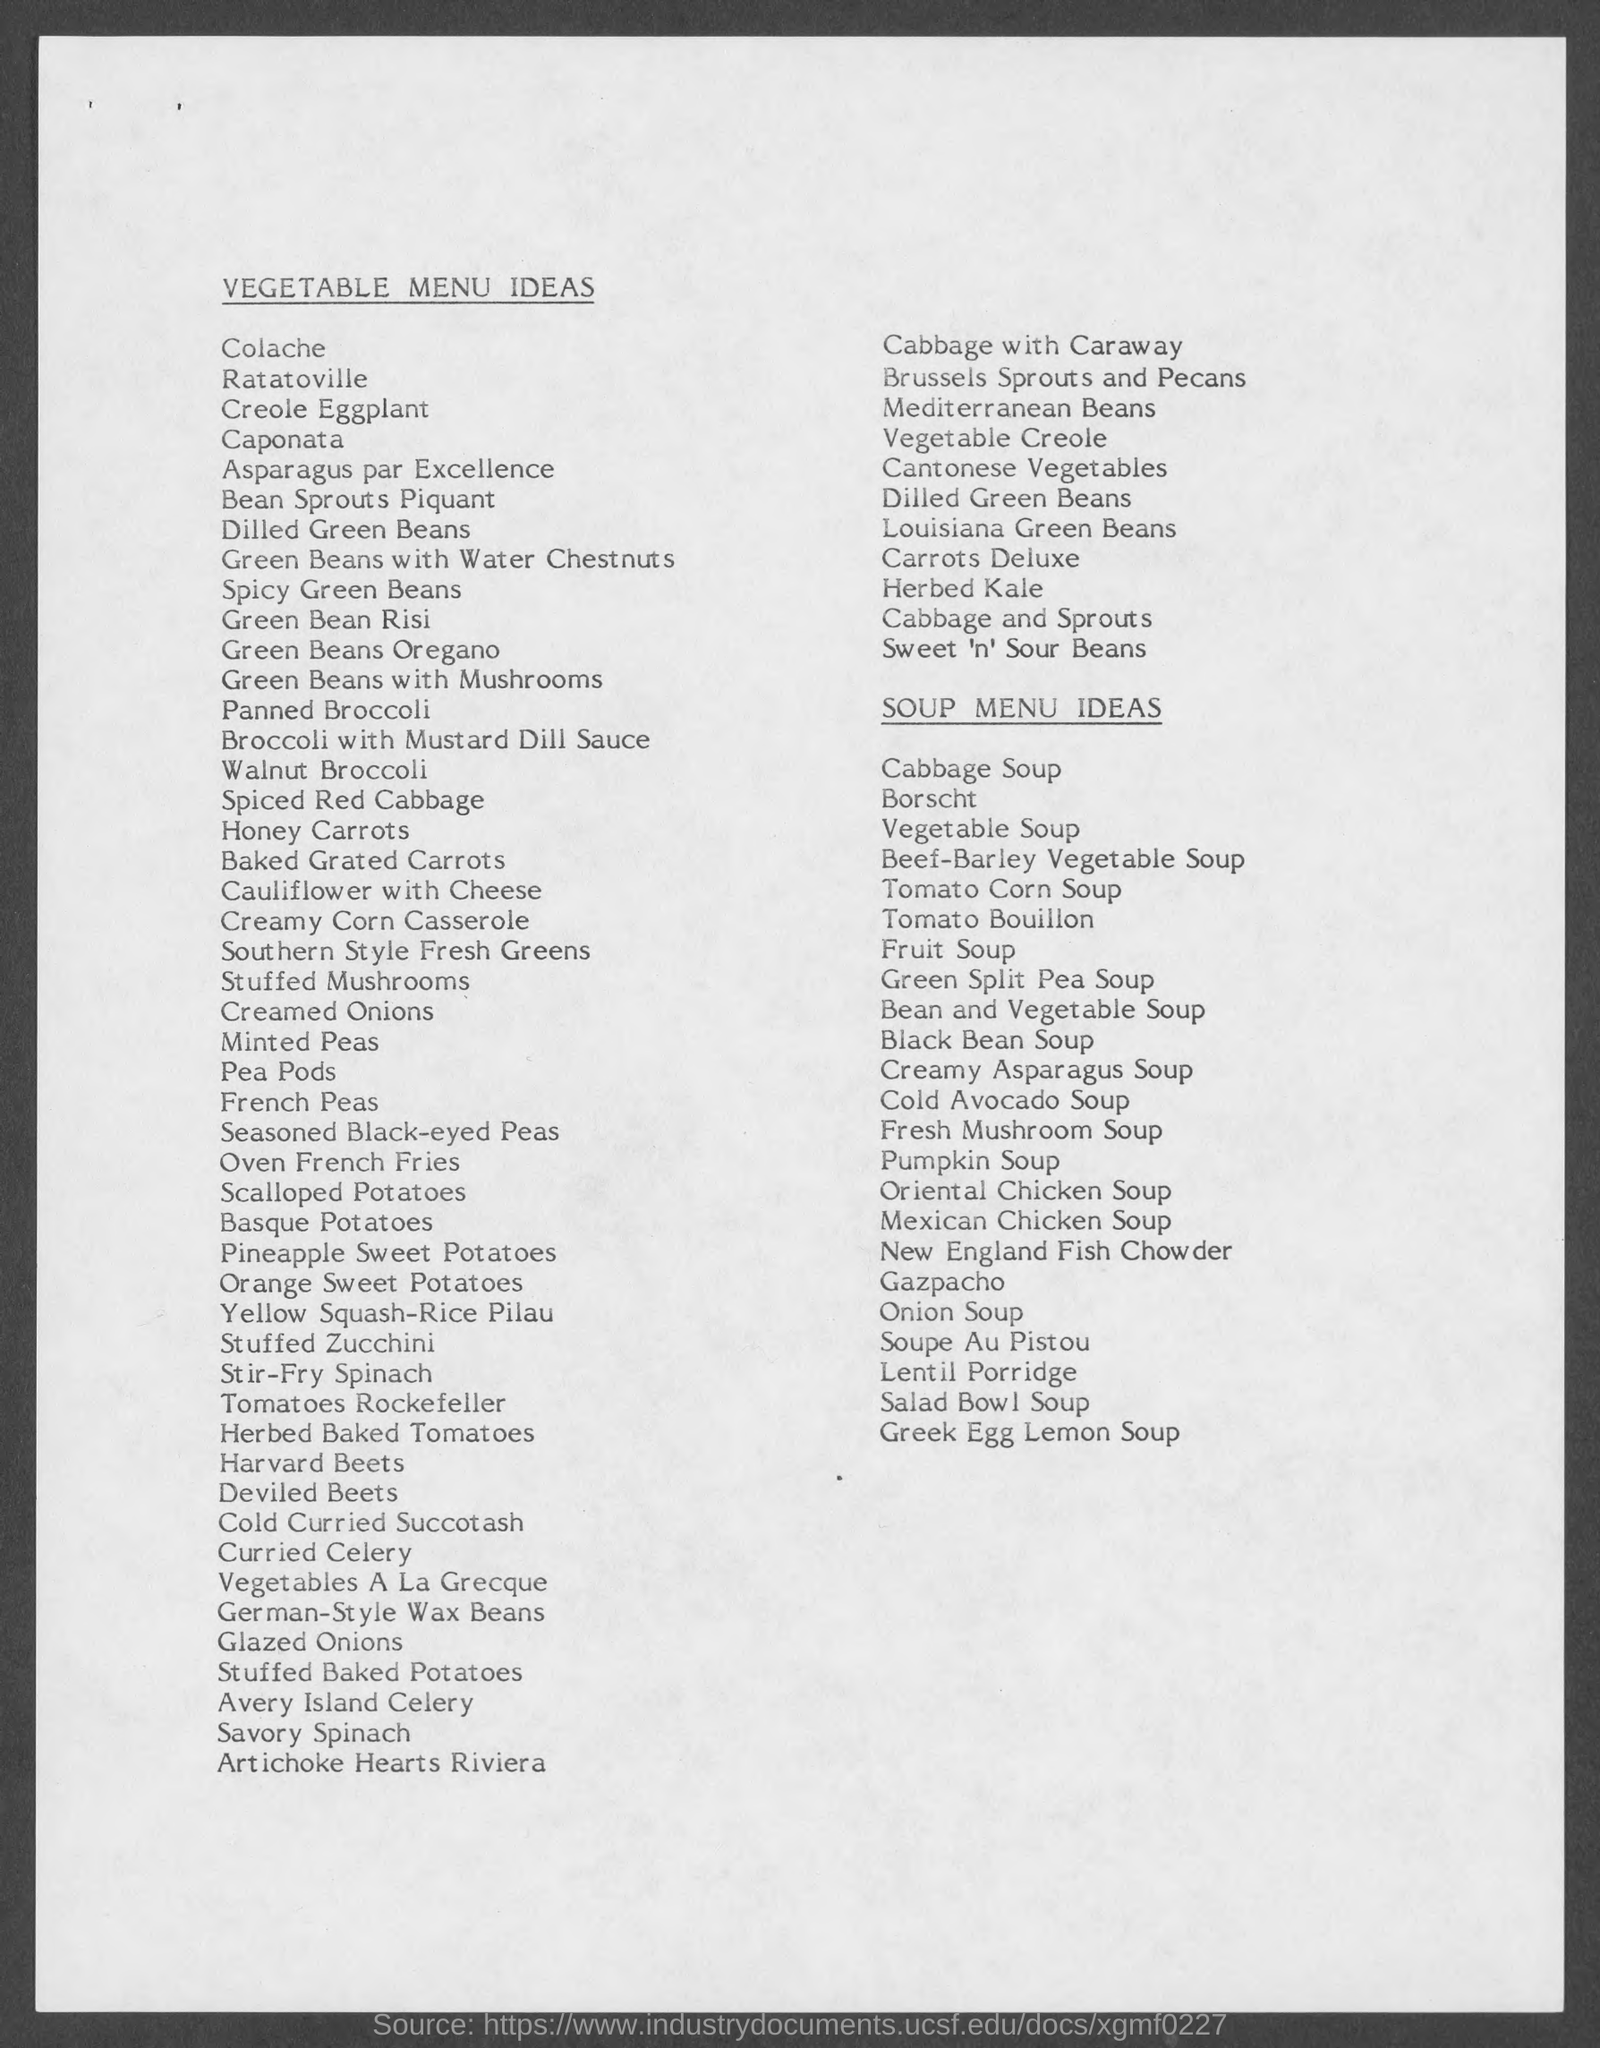Specify some key components in this picture. The title of the page is "Vegetable Menu Ideas. 